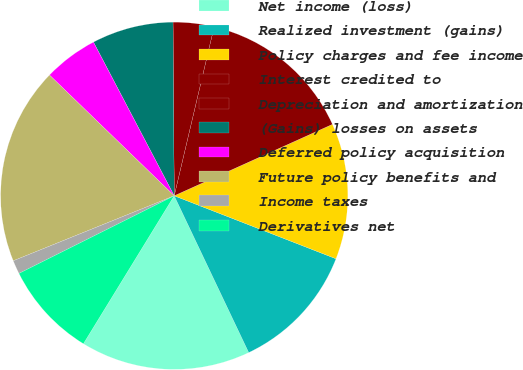Convert chart. <chart><loc_0><loc_0><loc_500><loc_500><pie_chart><fcel>Net income (loss)<fcel>Realized investment (gains)<fcel>Policy charges and fee income<fcel>Interest credited to<fcel>Depreciation and amortization<fcel>(Gains) losses on assets<fcel>Deferred policy acquisition<fcel>Future policy benefits and<fcel>Income taxes<fcel>Derivatives net<nl><fcel>15.82%<fcel>12.03%<fcel>12.66%<fcel>14.56%<fcel>3.8%<fcel>7.59%<fcel>5.06%<fcel>18.35%<fcel>1.27%<fcel>8.86%<nl></chart> 